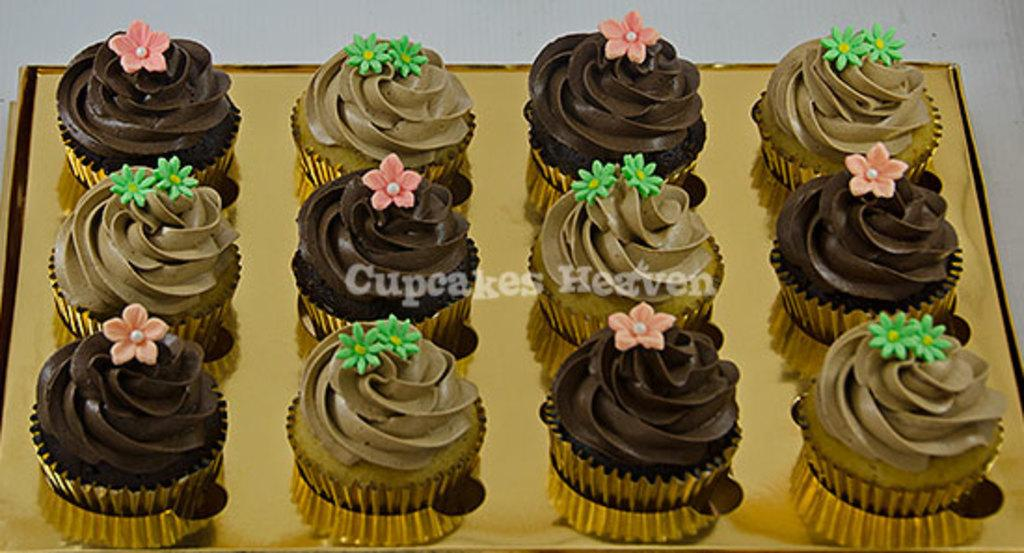What type of food can be seen in the image? There are cupcakes in the image. How are the cupcakes stored or contained? The cupcakes are kept in a box. What is the color of the box containing the cupcakes? The box is gold in color. What type of beam is holding up the cupcakes in the image? There is no beam present in the image; the cupcakes are kept in a box. Can you read any writing on the cupcakes in the image? There is no writing visible on the cupcakes in the image. 